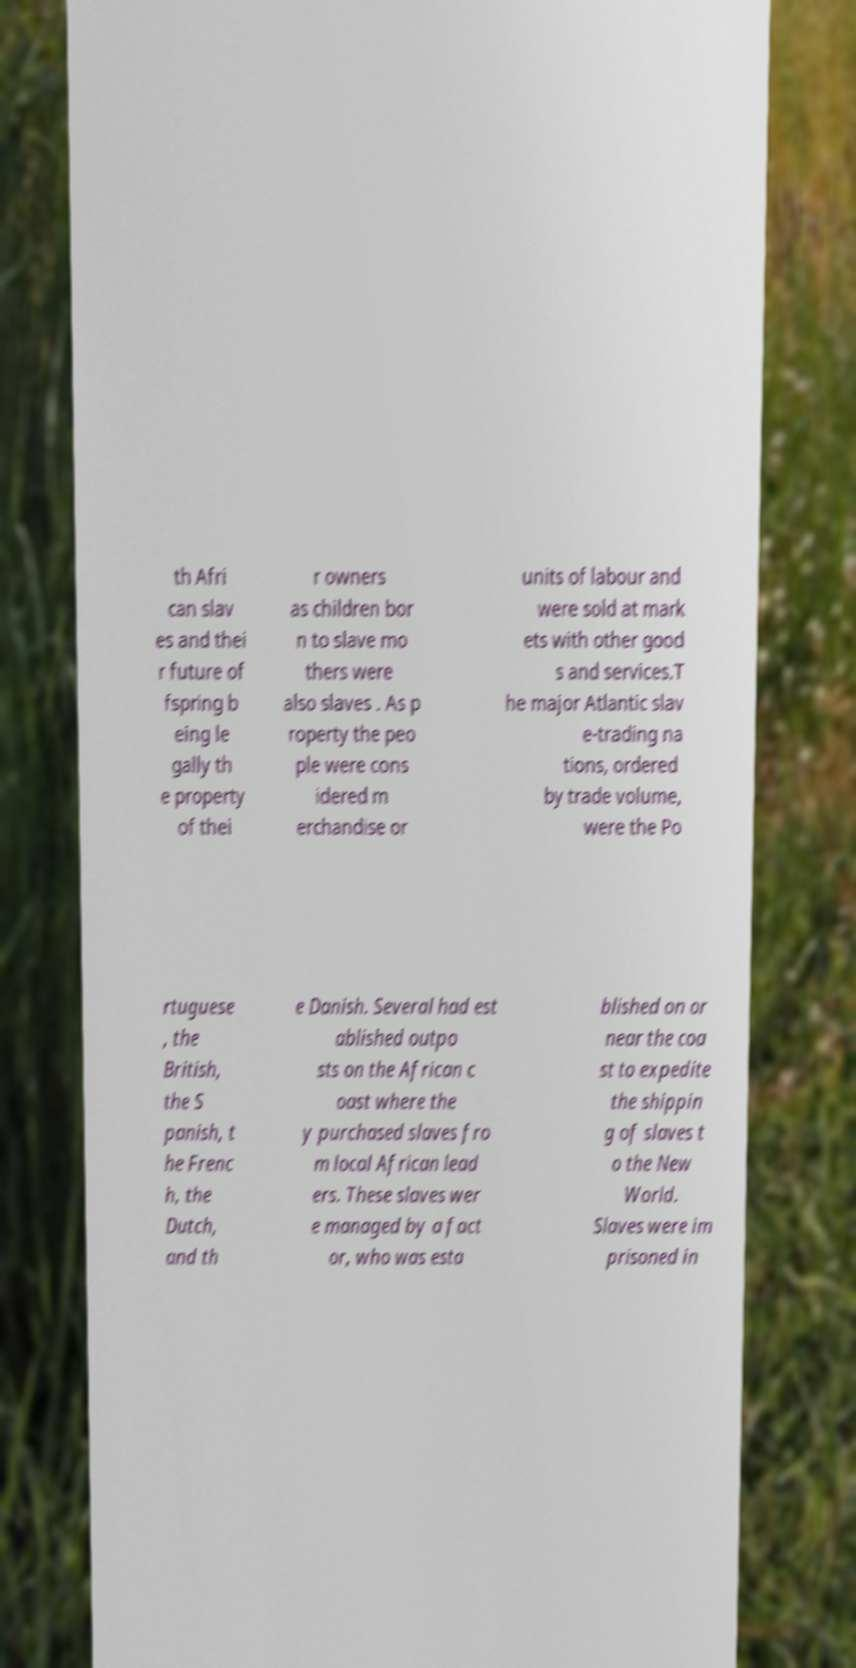There's text embedded in this image that I need extracted. Can you transcribe it verbatim? th Afri can slav es and thei r future of fspring b eing le gally th e property of thei r owners as children bor n to slave mo thers were also slaves . As p roperty the peo ple were cons idered m erchandise or units of labour and were sold at mark ets with other good s and services.T he major Atlantic slav e-trading na tions, ordered by trade volume, were the Po rtuguese , the British, the S panish, t he Frenc h, the Dutch, and th e Danish. Several had est ablished outpo sts on the African c oast where the y purchased slaves fro m local African lead ers. These slaves wer e managed by a fact or, who was esta blished on or near the coa st to expedite the shippin g of slaves t o the New World. Slaves were im prisoned in 